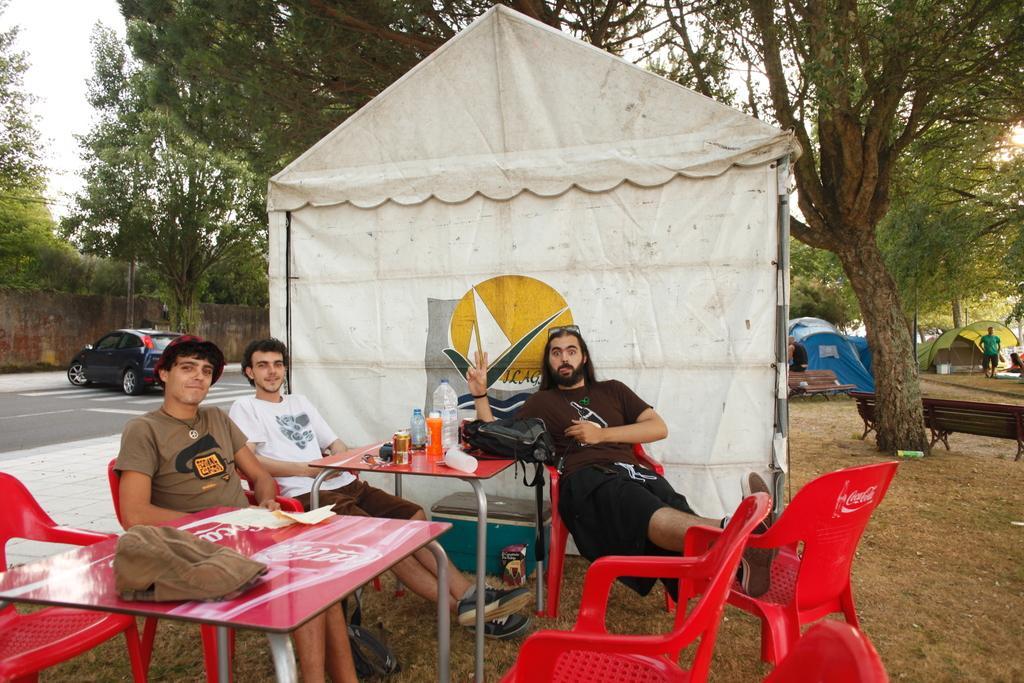How would you summarize this image in a sentence or two? There are three man sitting on chairs. There are two tables. On one table there is a dress. Another table there are some bottles. Behind them is a tent. In the background there is a car, trees, tents, benches and some person are standing there. 